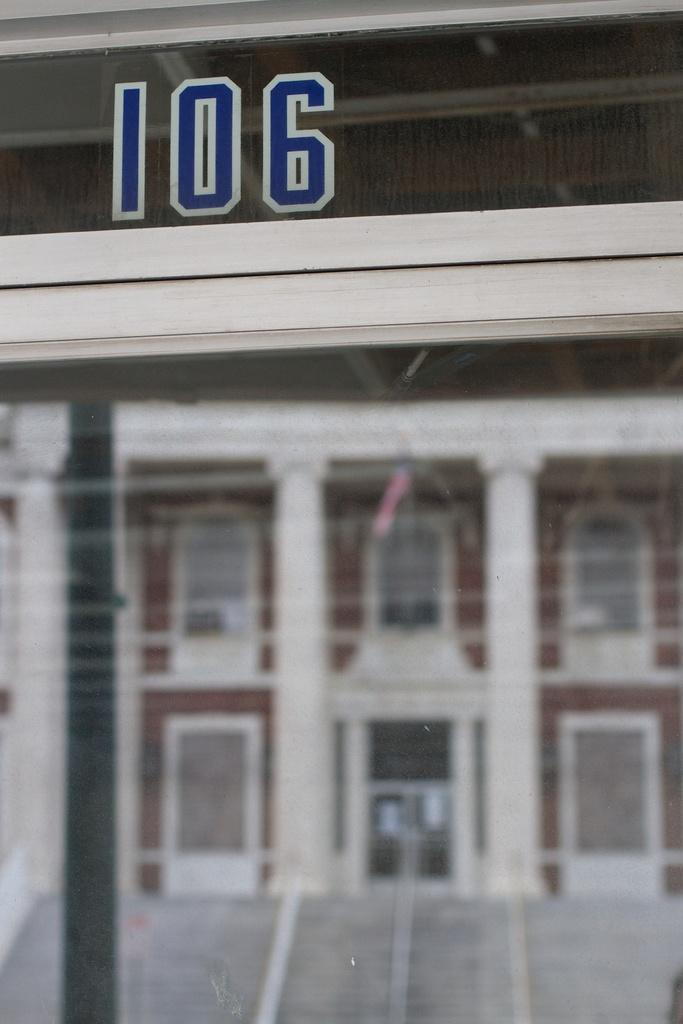<image>
Summarize the visual content of the image. A building is being shown with 106 at the top. 